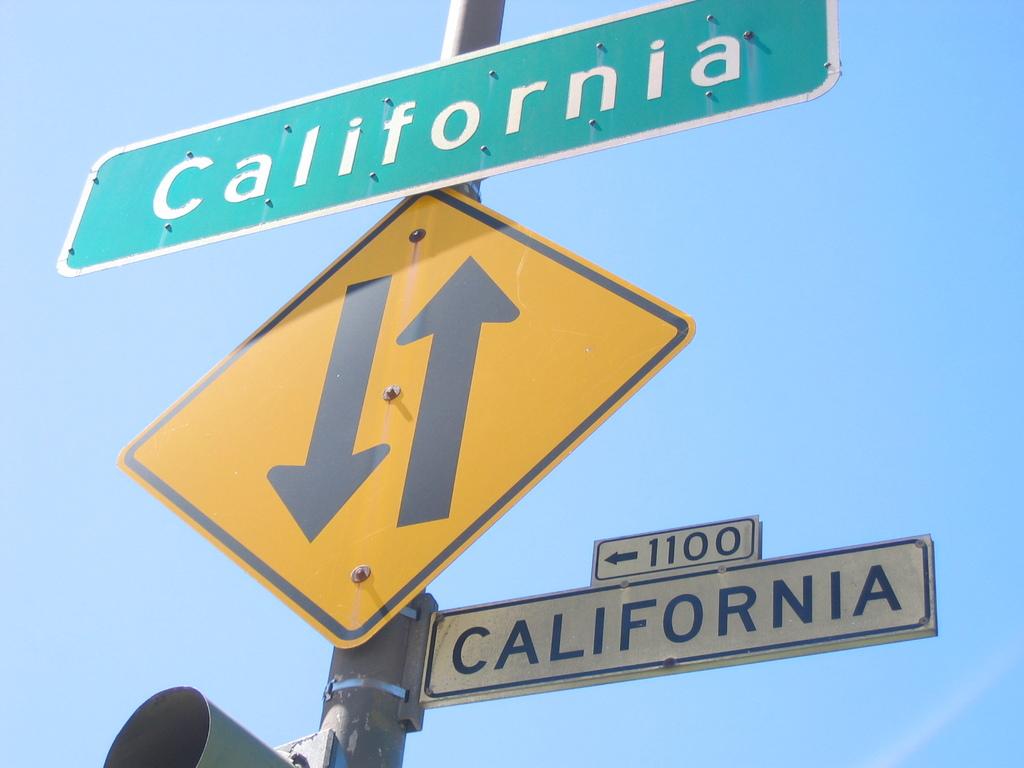What state is the sign in?
Your answer should be very brief. California. What street numbers are to the left?
Provide a short and direct response. 1100. 